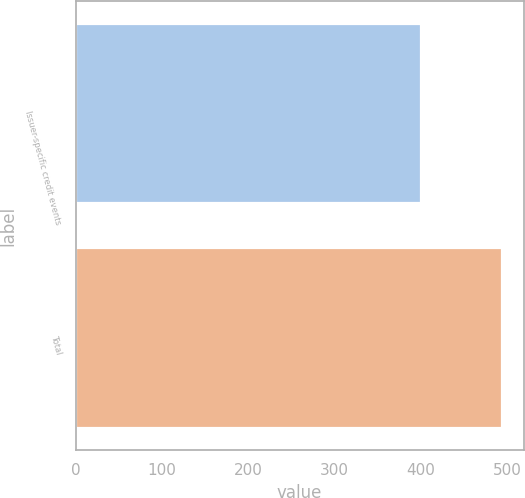Convert chart to OTSL. <chart><loc_0><loc_0><loc_500><loc_500><bar_chart><fcel>Issuer-specific credit events<fcel>Total<nl><fcel>400<fcel>494<nl></chart> 